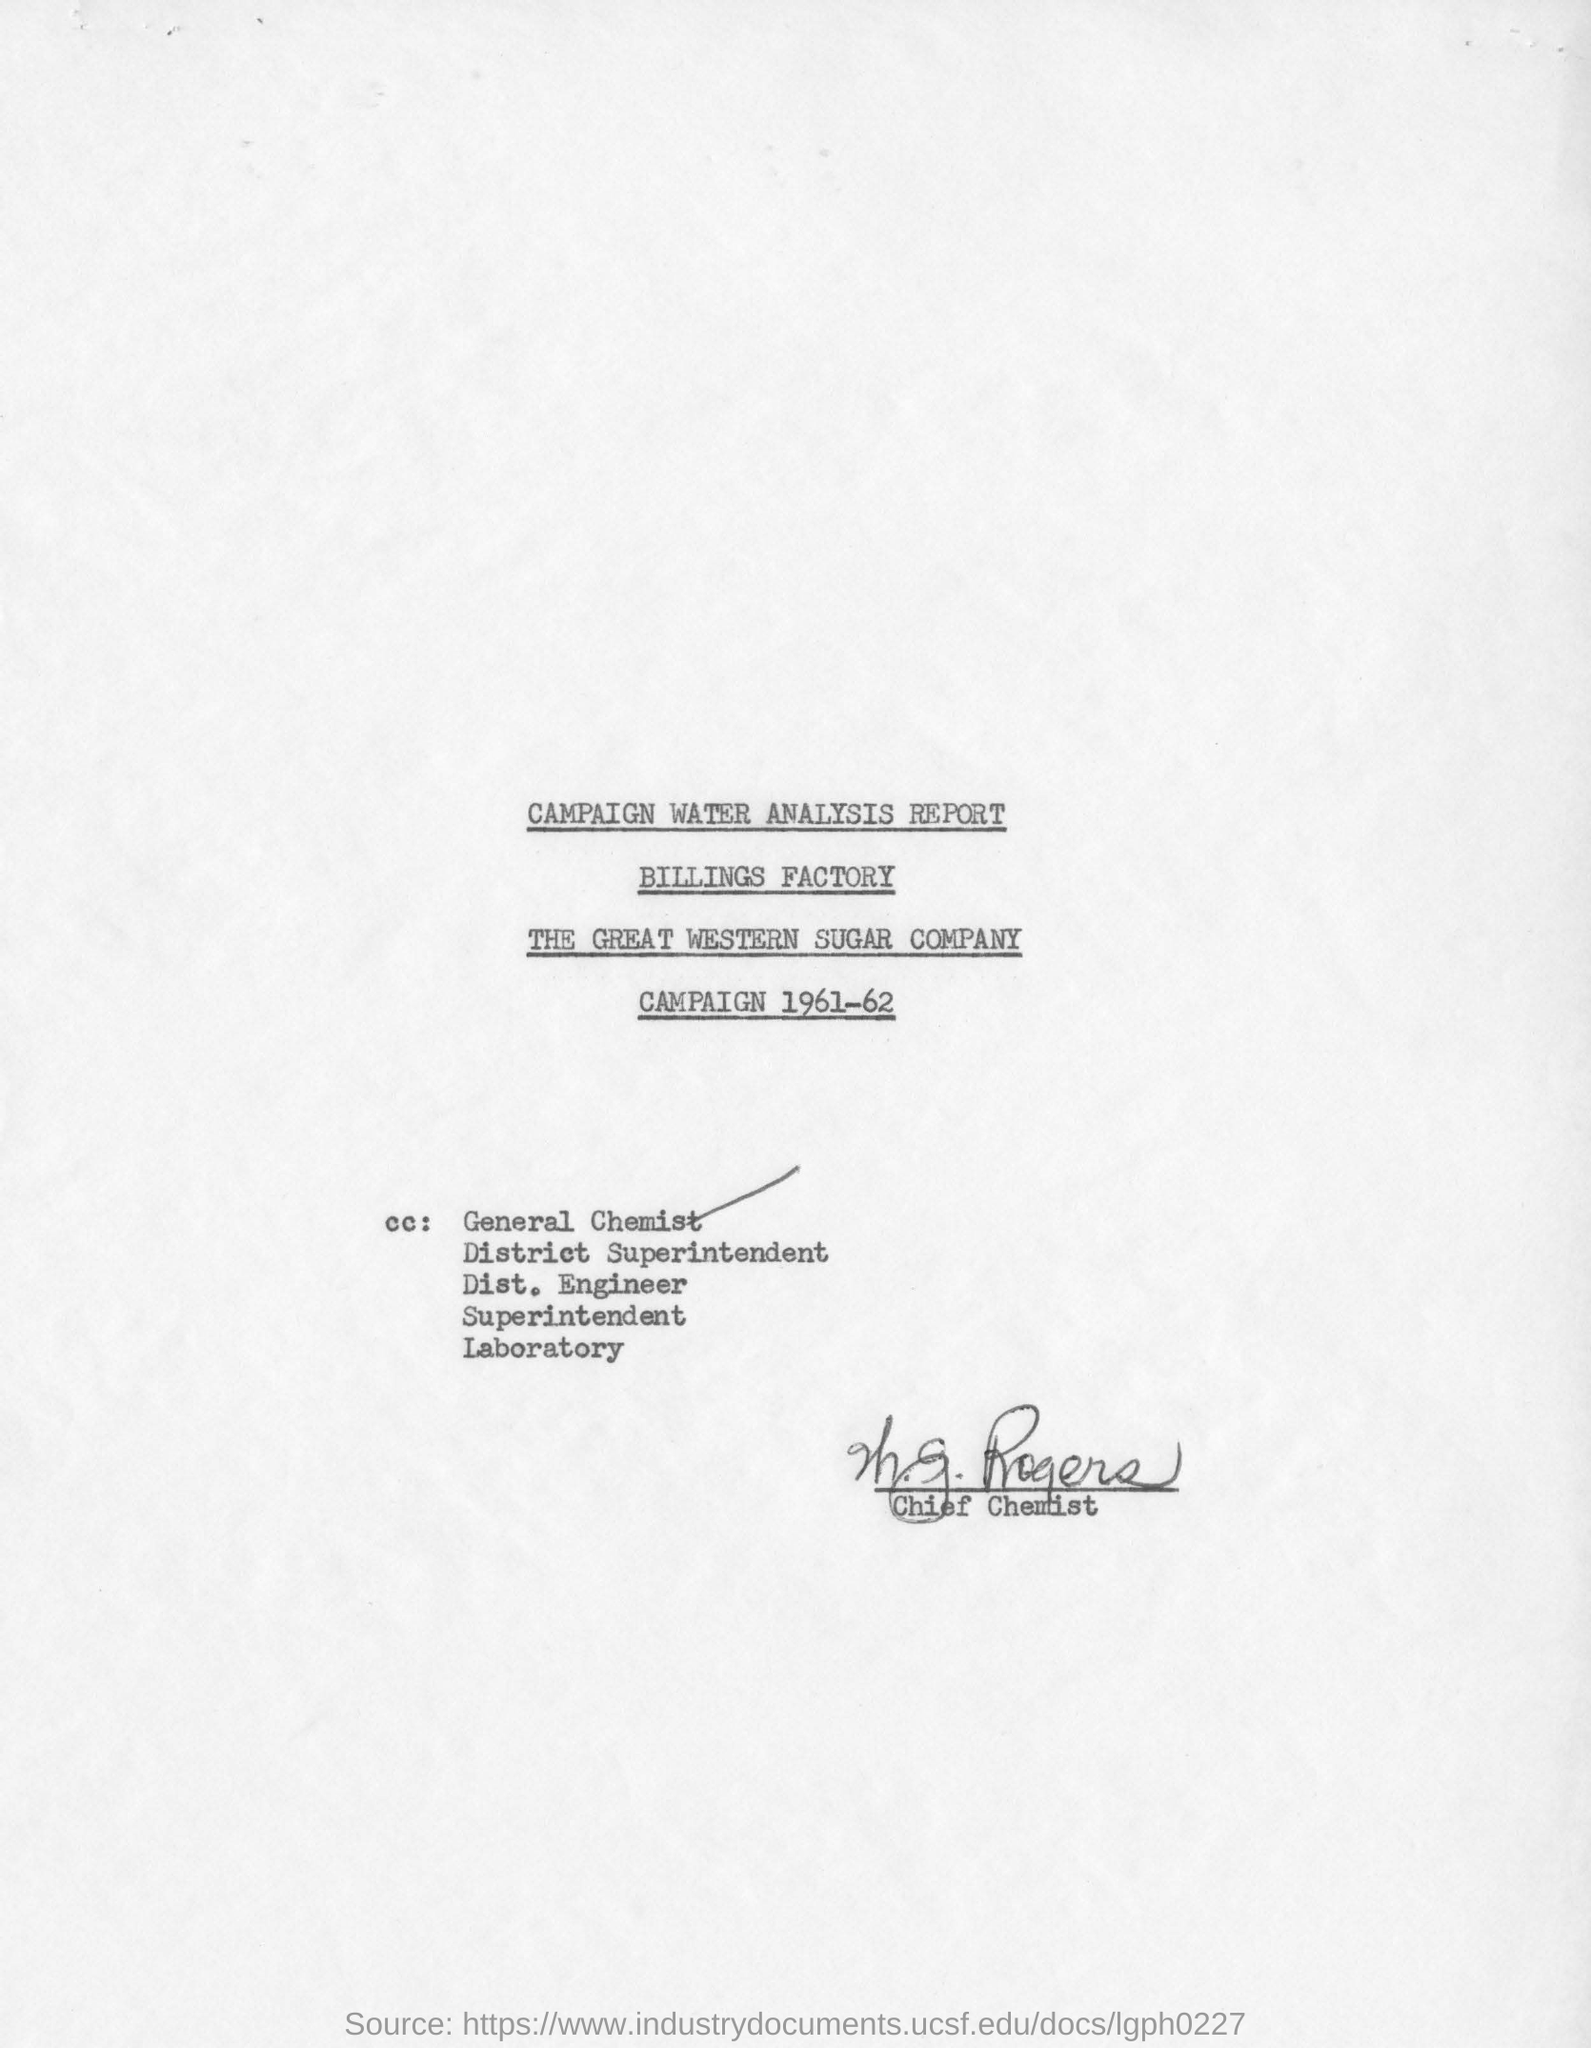What report is this?
Offer a very short reply. Campaign water analysis report. Which company mentioned in this page?
Give a very brief answer. THE GREAT WESTERN SUGAR COMPANY. Who signed in this document?
Offer a very short reply. Chief Chemist. 